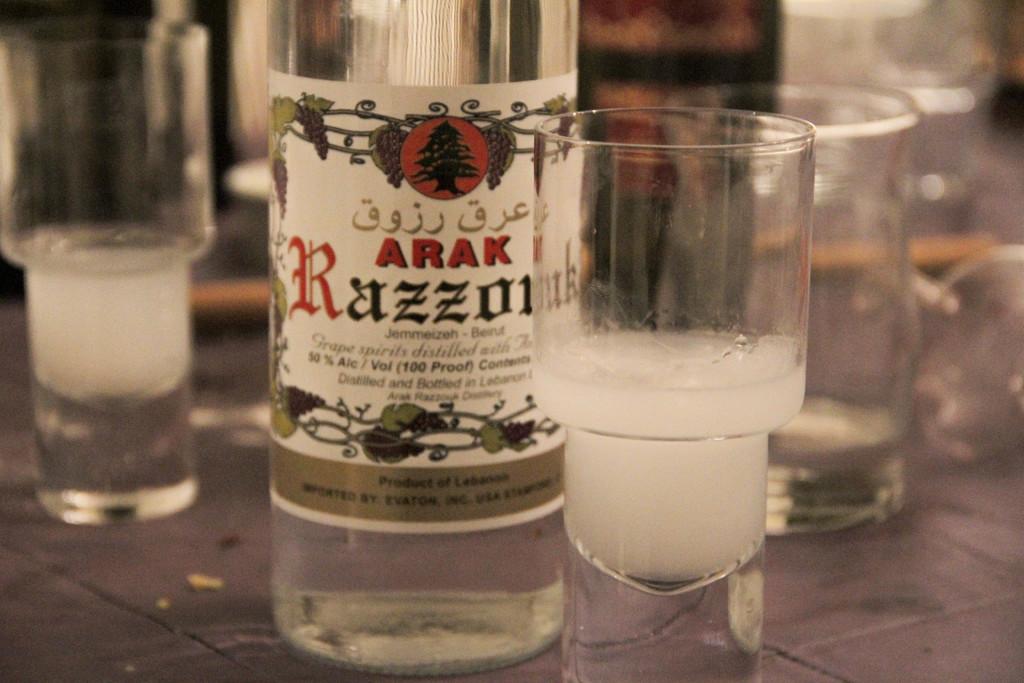What brand is the drink?
Provide a short and direct response. Arak. 